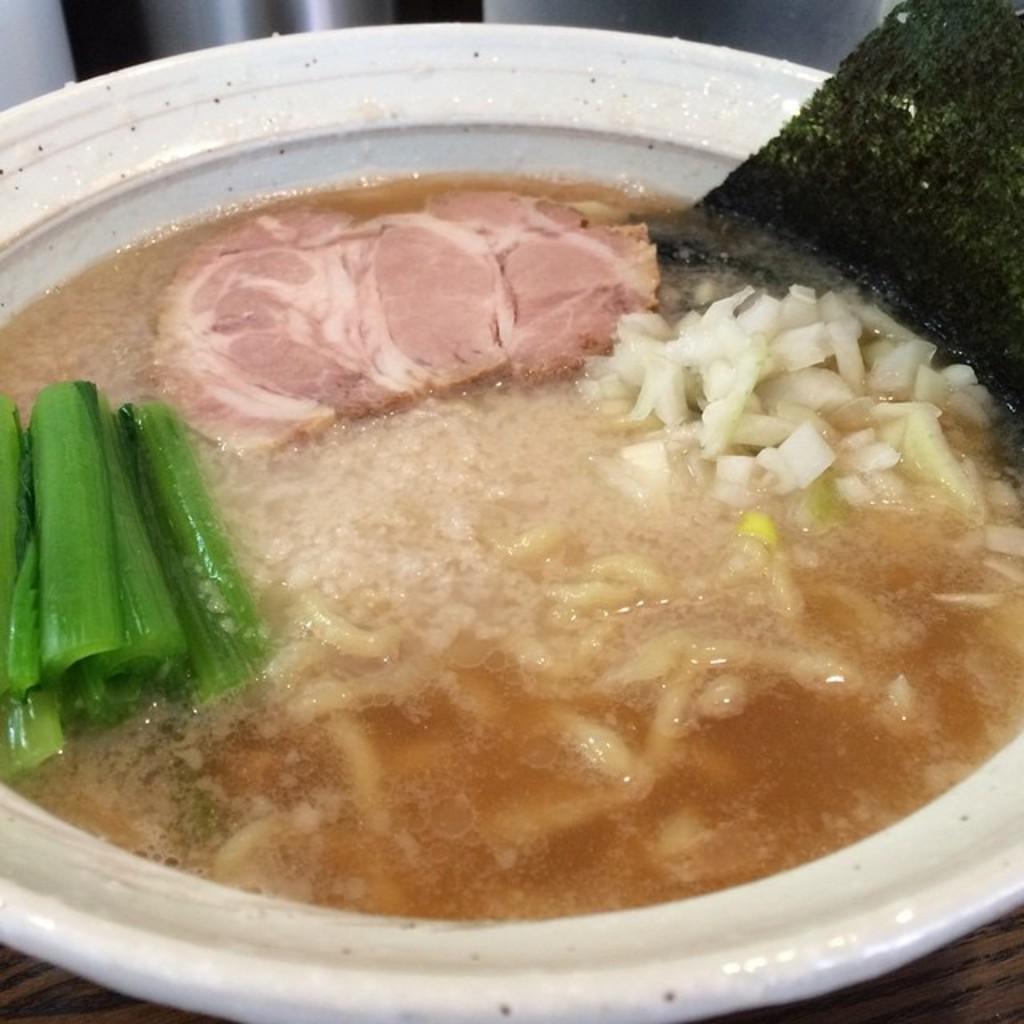Please provide a concise description of this image. In this picture I can see food in the bowl and I can see a table. 